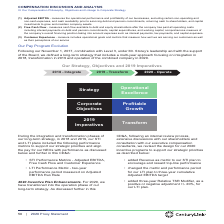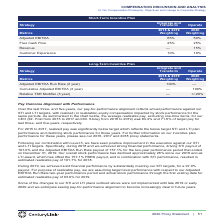According to Centurylink's financial document, Which metric was added under the Short-Term Incentive Plan for the 2020 incentive programs? According to the financial document, Revenue. The relevant text states: "Revenue — 15%..." Also, Why was Revenue added as a metric to the STI plan? to encourage and reward top-line performance. The document states: "• added Revenue as metric to our STI plan to encourage and reward top-line performance..." Also, Which metrics were added under the Long-Term Incentive Plan The document shows two values: Cumulative Adjusted EBITDA (3 year) and Relative TSR Modifier (3 year). From the document: "Relative TSR Modifier (3 year) — +/-20% Cumulative Adjusted EBITDA (3 year) — 100%..." Also, How many metrics were added under the Long-Term Incentive Plan? Counting the relevant items in the document: Cumulative Adjusted EBITDA (3 year), Relative TSR Modifier (3 year), I find 2 instances. The key data points involved are: Cumulative Adjusted EBITDA (3 year), Relative TSR Modifier (3 year). Also, can you calculate: What is the  change in the Adjusted EBITDA target under Short-Term Incentive Plan in 2020? Based on the calculation: 65%-50%, the result is 15 (percentage). This is based on the information: "Adjusted EBITDA 65% 50% Adjusted EBITDA 65% 50%..." The key data points involved are: 50, 65. Also, can you calculate: What is the average Adjusted EBITDA under the Short-Term Incentive Plan? To answer this question, I need to perform calculations using the financial data. The calculation is: (65%+50%)/2, which equals 57.5 (percentage). This is based on the information: "Adjusted EBITDA 65% 50% Metrics 2018 & 2019 Weighting 2020 Weighting Adjusted EBITDA 65% 50%..." The key data points involved are: 2, 50, 65. 